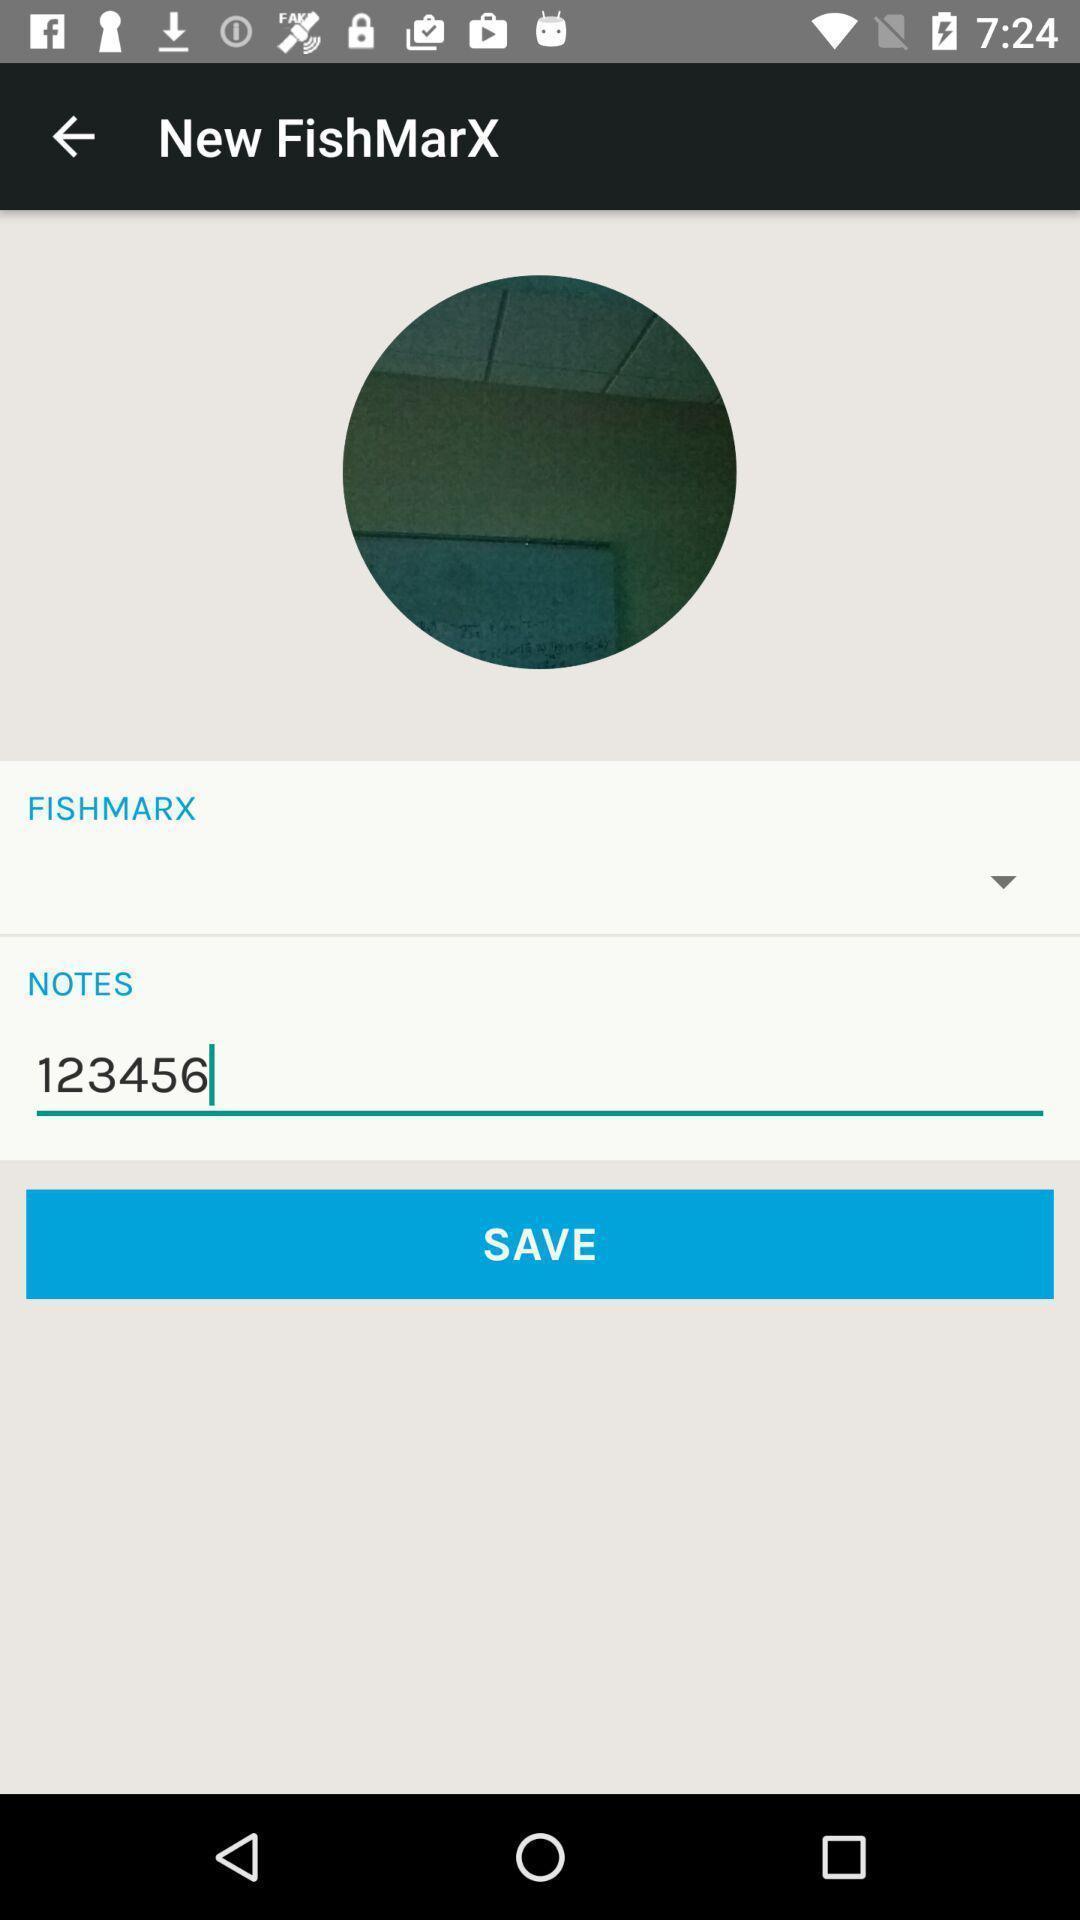Provide a detailed account of this screenshot. Screen displaying multiple options in a mapping application. 